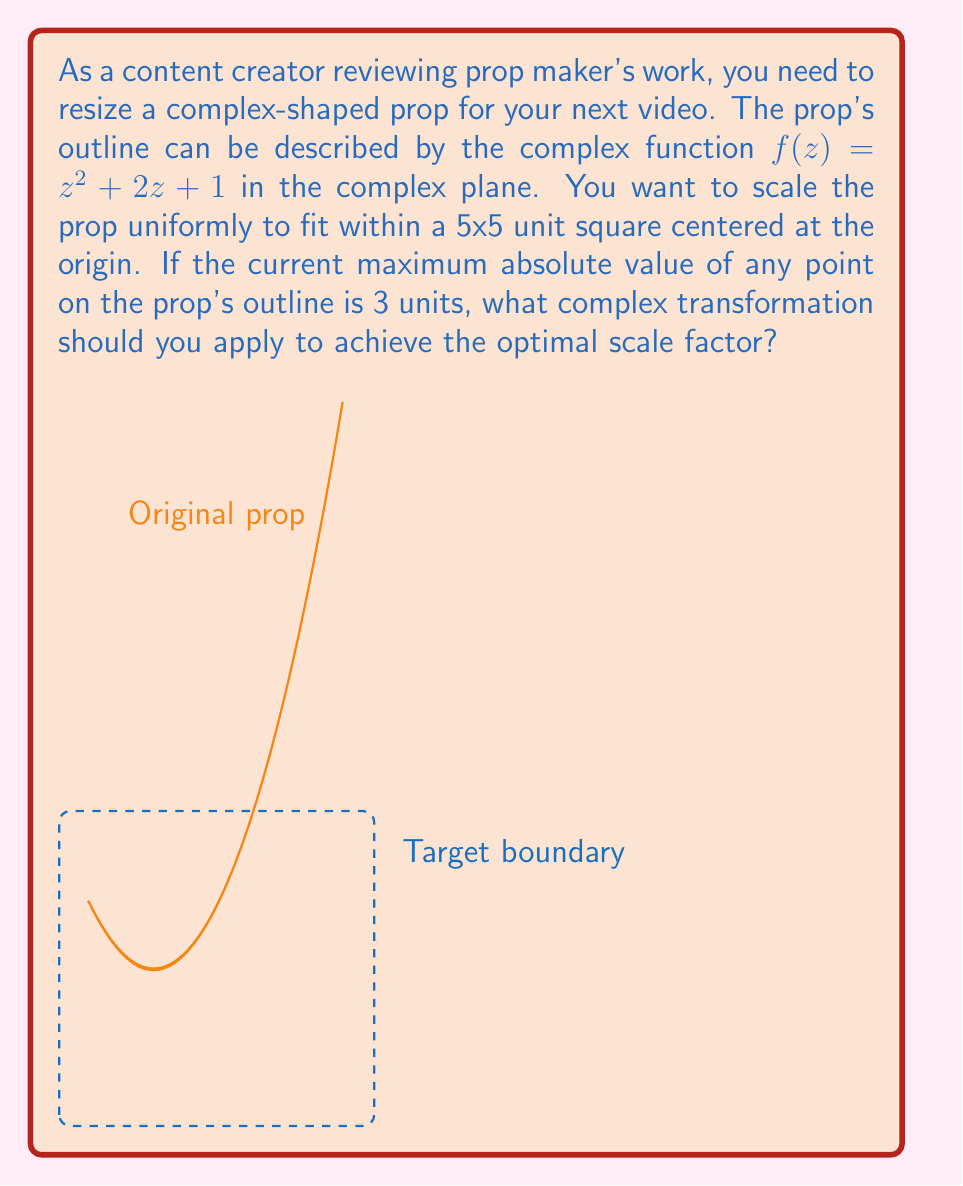What is the answer to this math problem? Let's approach this step-by-step:

1) The current maximum absolute value of any point on the prop's outline is 3 units. We want to scale it to fit within a 5x5 unit square centered at the origin.

2) The maximum distance from the origin to any point on the new prop should be 2.5 units (half of the 5x5 square).

3) To achieve this, we need to scale the prop by a factor of $\frac{2.5}{3}$.

4) In complex analysis, scaling is achieved by multiplying the complex function by a real number. Let's call our scaling factor $k$.

5) The transformed function will be:

   $g(z) = k \cdot f(z) = k(z^2 + 2z + 1)$

6) We calculated that $k = \frac{2.5}{3}$

7) Therefore, the complex transformation we need to apply is:

   $g(z) = \frac{2.5}{3}(z^2 + 2z + 1)$

8) This can be simplified to:

   $g(z) = \frac{5}{6}z^2 + \frac{5}{3}z + \frac{5}{6}$

This transformation will scale the prop uniformly to fit within the 5x5 unit square while maintaining its shape.
Answer: $g(z) = \frac{5}{6}z^2 + \frac{5}{3}z + \frac{5}{6}$ 